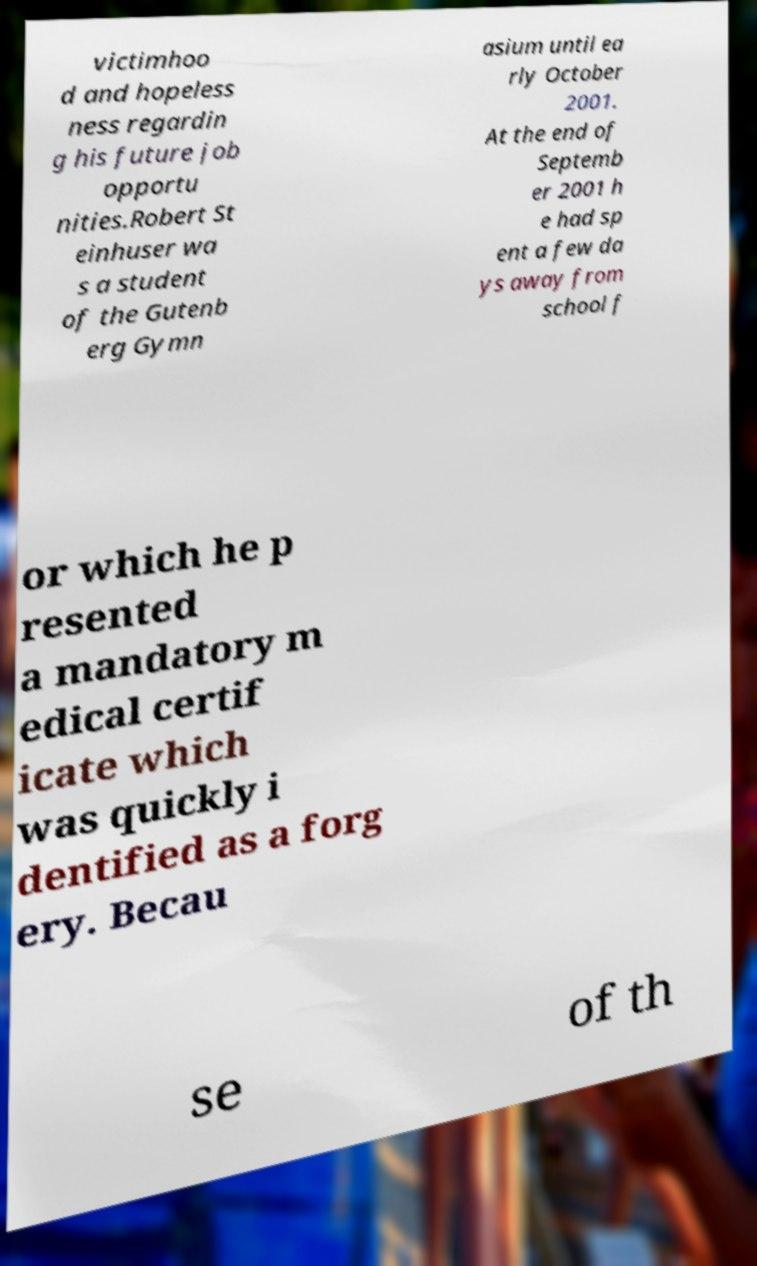I need the written content from this picture converted into text. Can you do that? victimhoo d and hopeless ness regardin g his future job opportu nities.Robert St einhuser wa s a student of the Gutenb erg Gymn asium until ea rly October 2001. At the end of Septemb er 2001 h e had sp ent a few da ys away from school f or which he p resented a mandatory m edical certif icate which was quickly i dentified as a forg ery. Becau se of th 